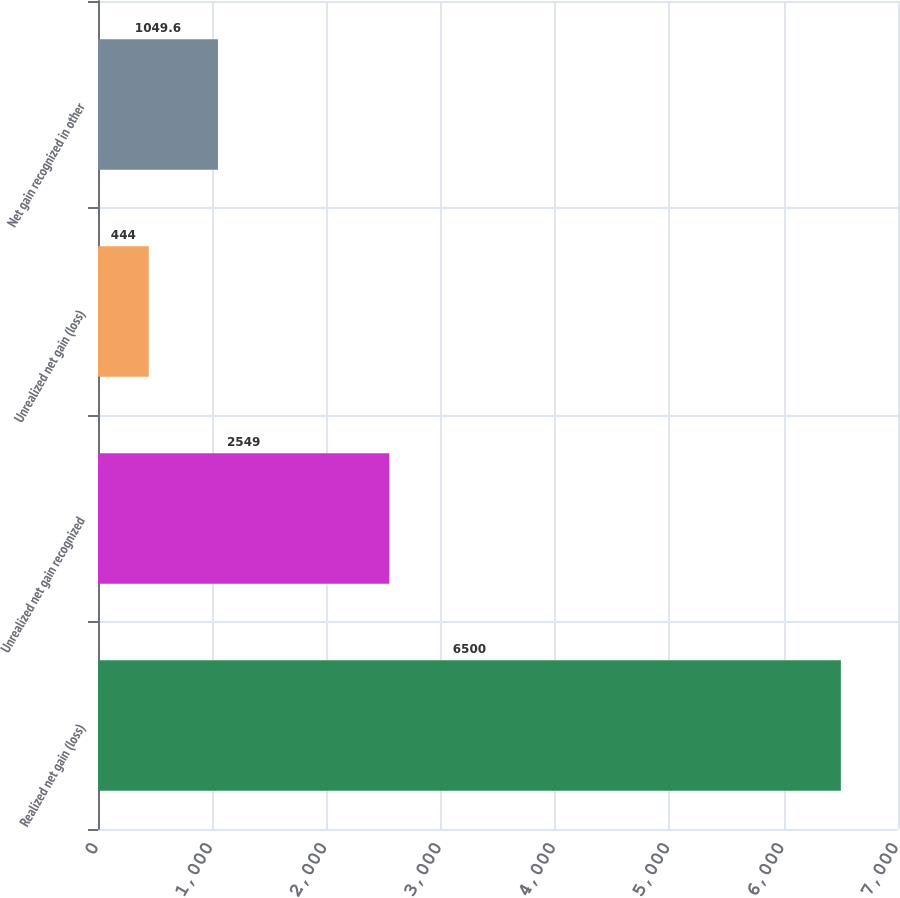<chart> <loc_0><loc_0><loc_500><loc_500><bar_chart><fcel>Realized net gain (loss)<fcel>Unrealized net gain recognized<fcel>Unrealized net gain (loss)<fcel>Net gain recognized in other<nl><fcel>6500<fcel>2549<fcel>444<fcel>1049.6<nl></chart> 